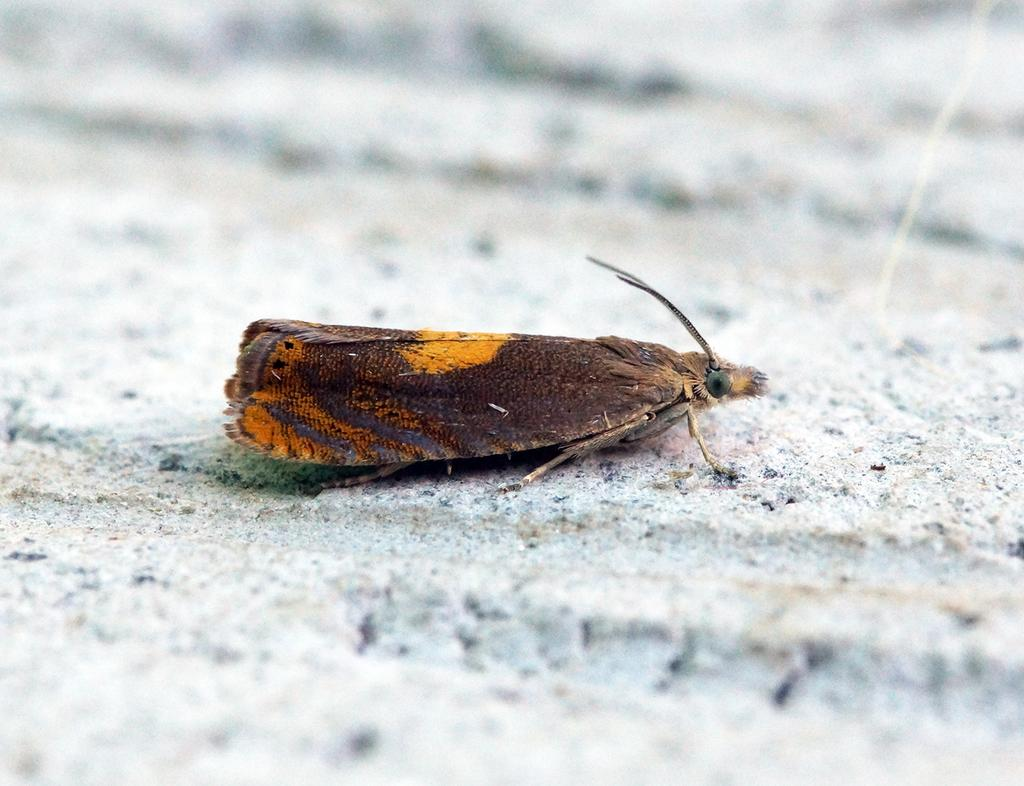What is the main subject of the image? There is an insect in the center of the image. What type of picture is hanging on the wall in the image? There is no mention of a picture or a wall in the image; the main subject is an insect. 